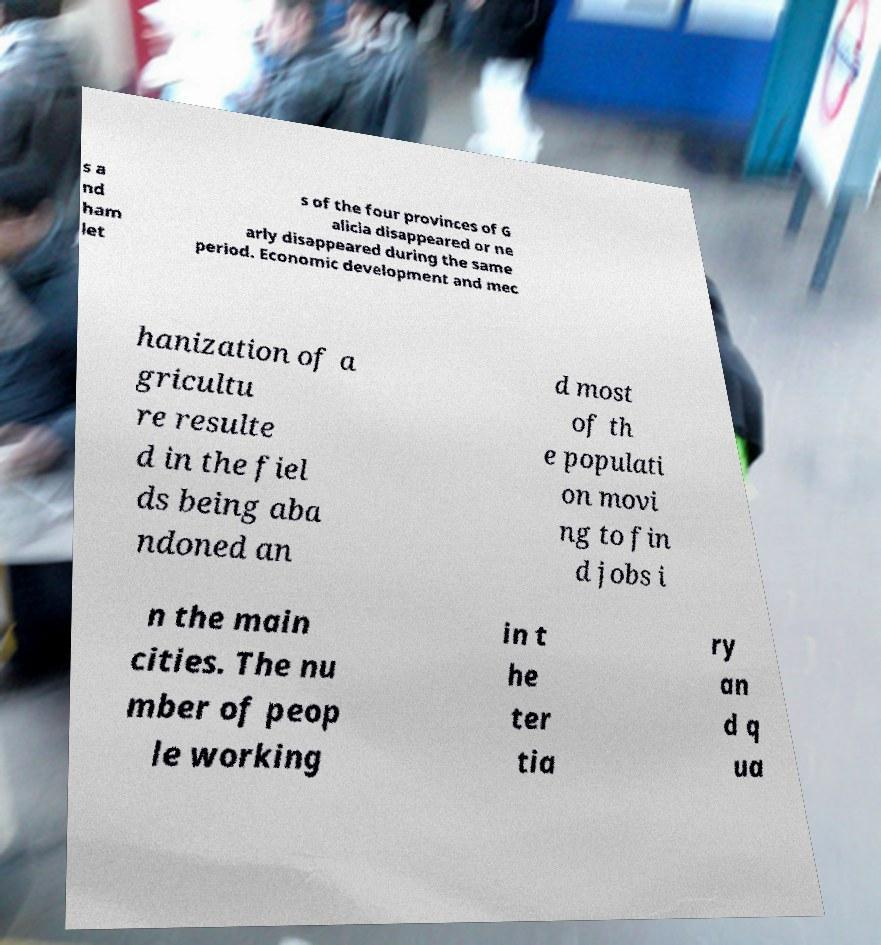What messages or text are displayed in this image? I need them in a readable, typed format. s a nd ham let s of the four provinces of G alicia disappeared or ne arly disappeared during the same period. Economic development and mec hanization of a gricultu re resulte d in the fiel ds being aba ndoned an d most of th e populati on movi ng to fin d jobs i n the main cities. The nu mber of peop le working in t he ter tia ry an d q ua 